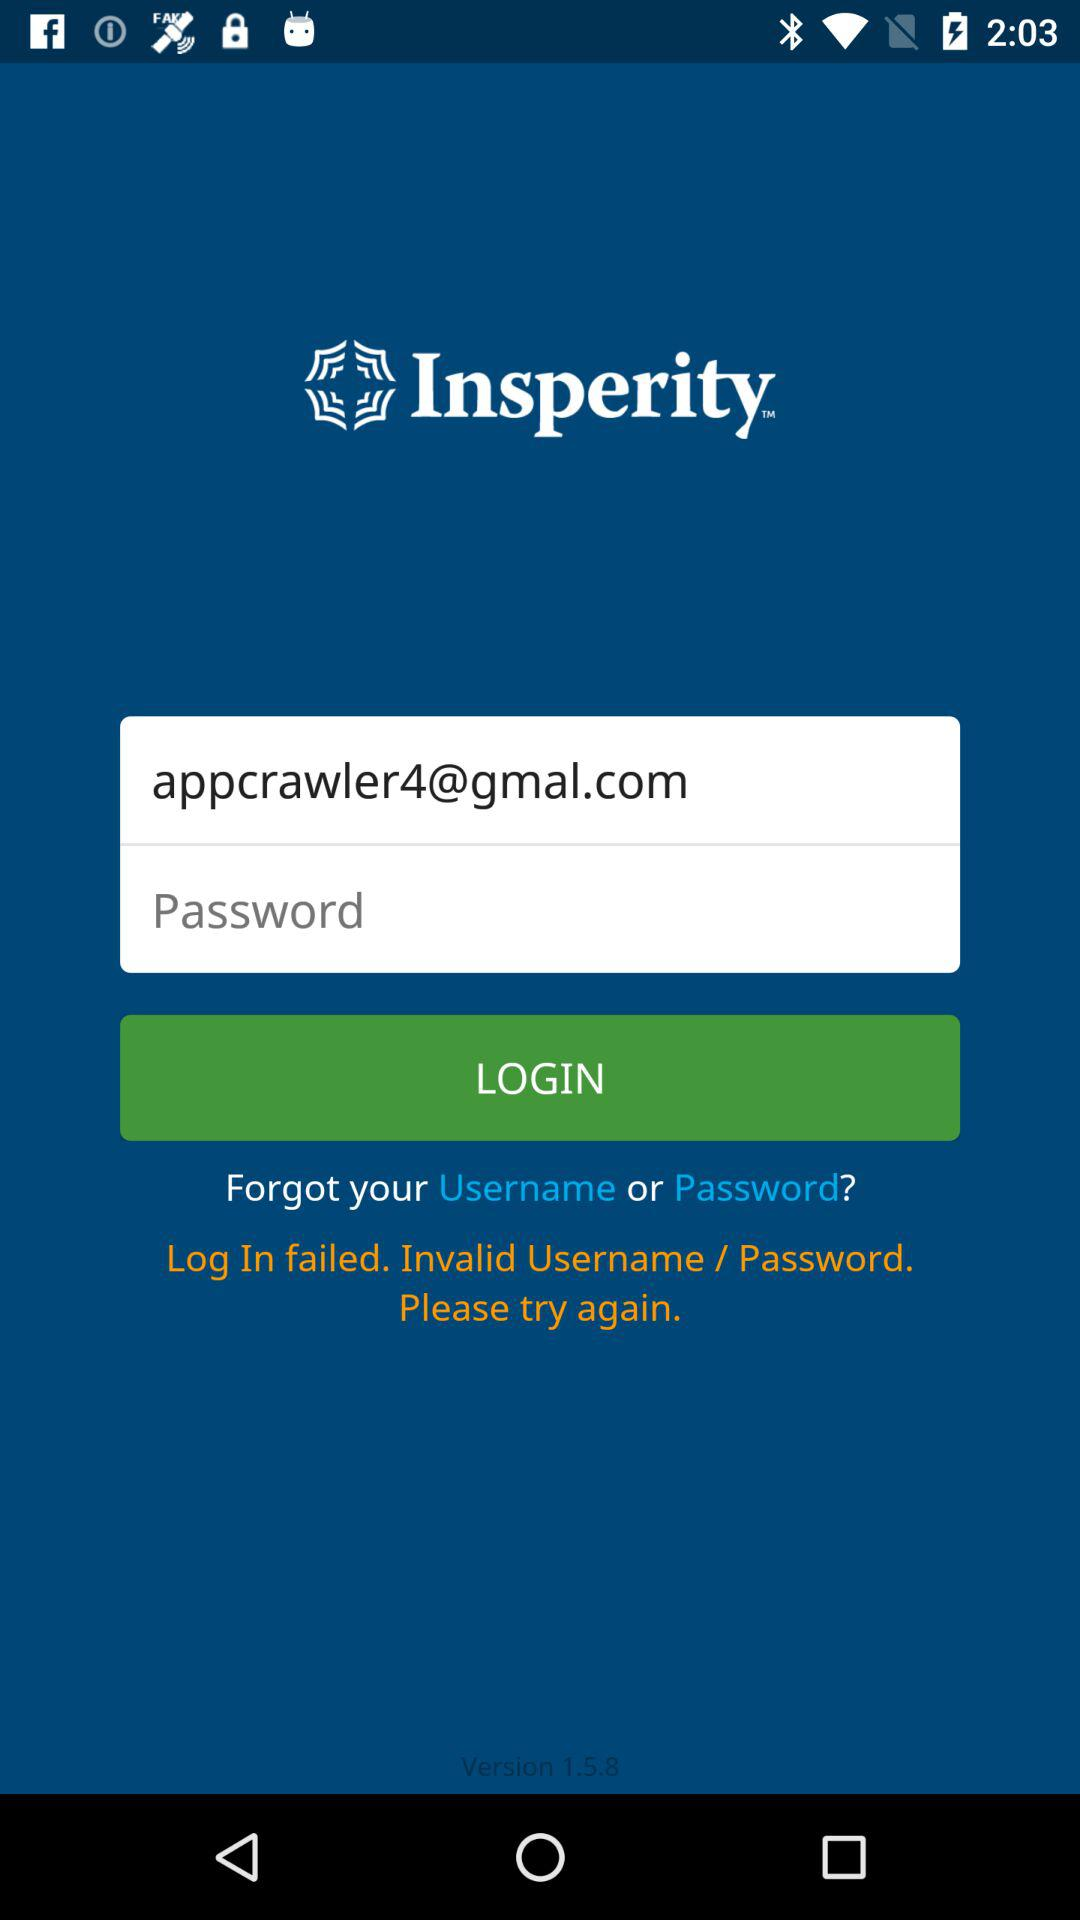What is the email address? The email address is "appcrawler4@gmal.com". 